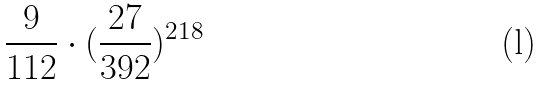<formula> <loc_0><loc_0><loc_500><loc_500>\frac { 9 } { 1 1 2 } \cdot ( \frac { 2 7 } { 3 9 2 } ) ^ { 2 1 8 }</formula> 